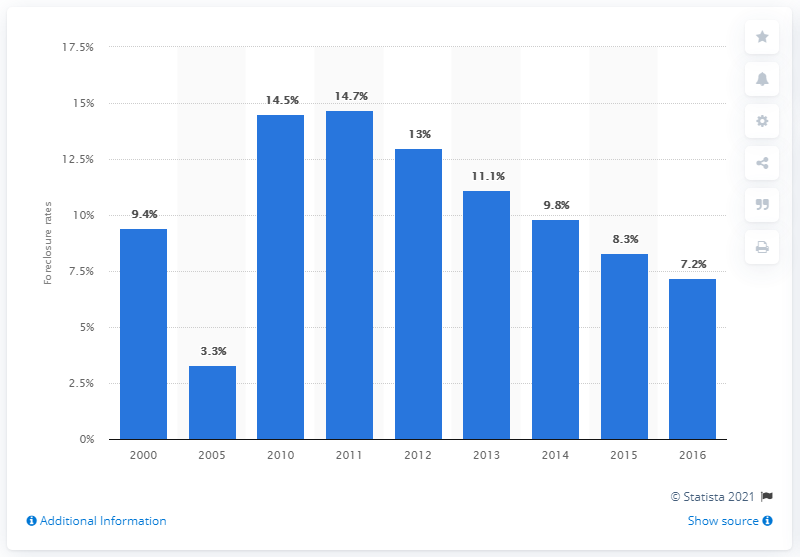List a handful of essential elements in this visual. In 2016, a significant portion, or 7.2%, of subprime conventional loans were in foreclosure. 